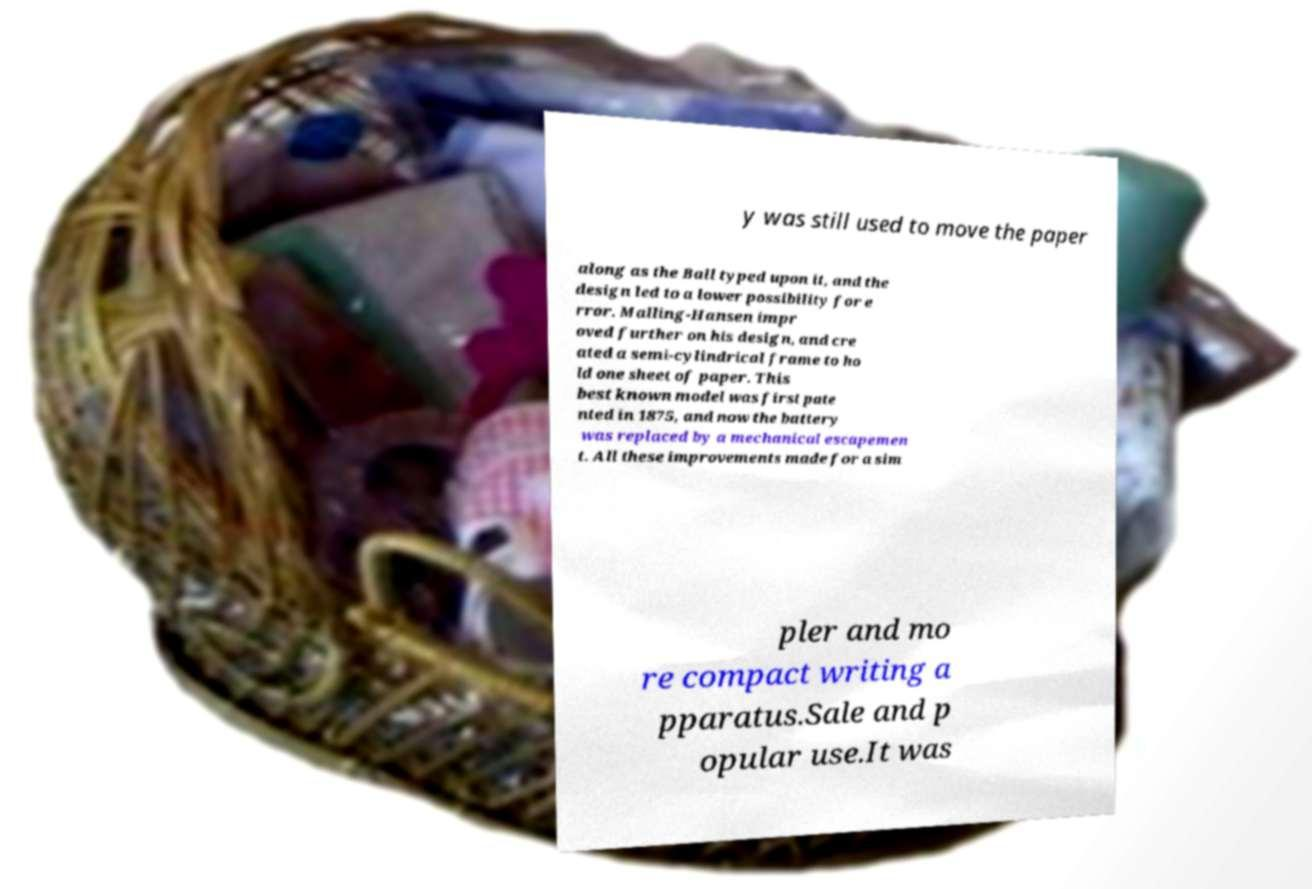What messages or text are displayed in this image? I need them in a readable, typed format. y was still used to move the paper along as the Ball typed upon it, and the design led to a lower possibility for e rror. Malling-Hansen impr oved further on his design, and cre ated a semi-cylindrical frame to ho ld one sheet of paper. This best known model was first pate nted in 1875, and now the battery was replaced by a mechanical escapemen t. All these improvements made for a sim pler and mo re compact writing a pparatus.Sale and p opular use.It was 